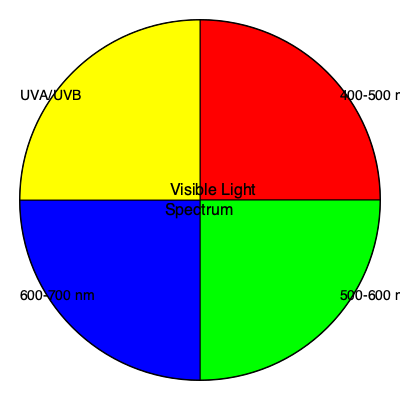Which wavelength range in the visible light spectrum has been shown to have the most significant impact on melanin production and skin pigmentation, and why is this knowledge important for developing targeted skincare products? 1. The visible light spectrum ranges from approximately 400 to 700 nanometers (nm).

2. Different wavelengths within this spectrum have varying effects on the skin:
   a) 400-500 nm (blue light): Can penetrate deeper into the skin and may contribute to oxidative stress.
   b) 500-600 nm (green light): Generally considered to have minimal impact on skin pigmentation.
   c) 600-700 nm (red light): Has been shown to have some beneficial effects on skin, such as promoting collagen production.

3. Research has shown that the wavelength range of 400-500 nm, particularly blue light, has the most significant impact on melanin production and skin pigmentation.

4. Blue light stimulates melanocytes, the cells responsible for producing melanin, leading to increased pigmentation.

5. This knowledge is important for developing targeted skincare products because:
   a) It allows for the creation of specific sunscreens that protect against blue light, not just UV radiation.
   b) It enables the development of products that can help prevent or treat hyperpigmentation caused by blue light exposure.
   c) It informs the design of light therapy devices for treating various skin conditions.

6. Understanding the impact of different wavelengths on skin pigmentation allows dermatologists to provide more comprehensive advice to patients regarding skin protection and treatment options.
Answer: 400-500 nm (blue light) 